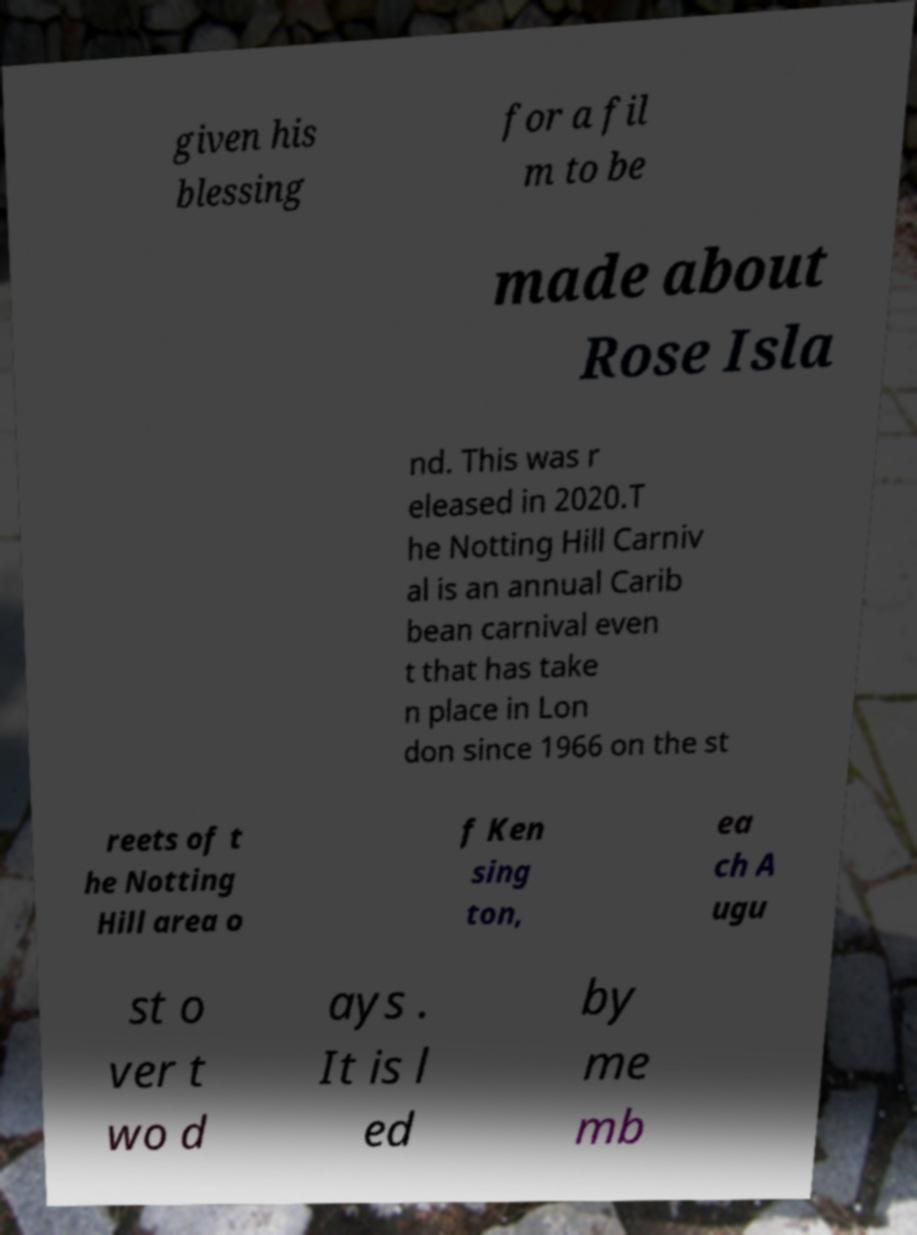For documentation purposes, I need the text within this image transcribed. Could you provide that? given his blessing for a fil m to be made about Rose Isla nd. This was r eleased in 2020.T he Notting Hill Carniv al is an annual Carib bean carnival even t that has take n place in Lon don since 1966 on the st reets of t he Notting Hill area o f Ken sing ton, ea ch A ugu st o ver t wo d ays . It is l ed by me mb 